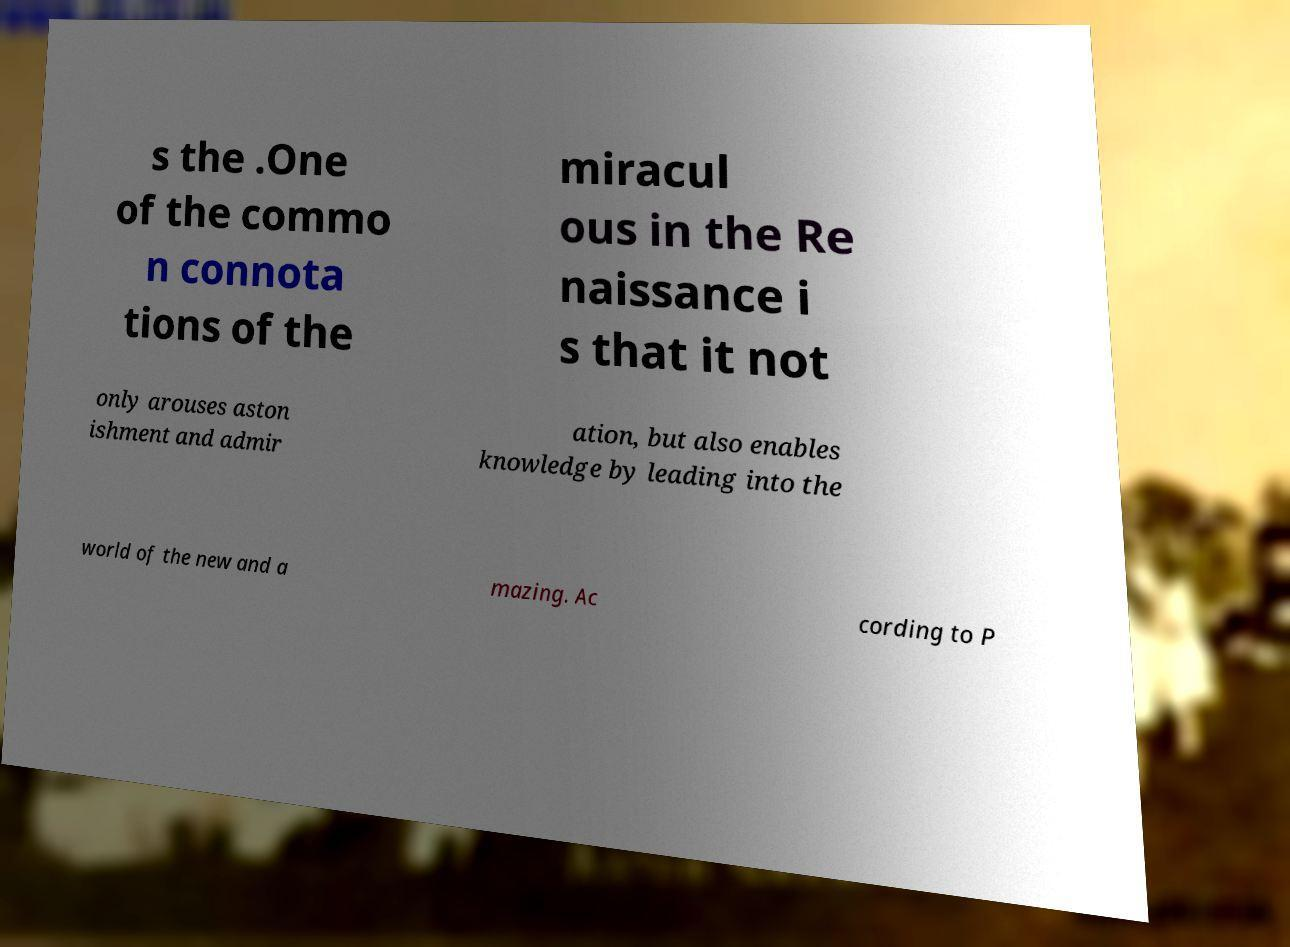Could you assist in decoding the text presented in this image and type it out clearly? s the .One of the commo n connota tions of the miracul ous in the Re naissance i s that it not only arouses aston ishment and admir ation, but also enables knowledge by leading into the world of the new and a mazing. Ac cording to P 